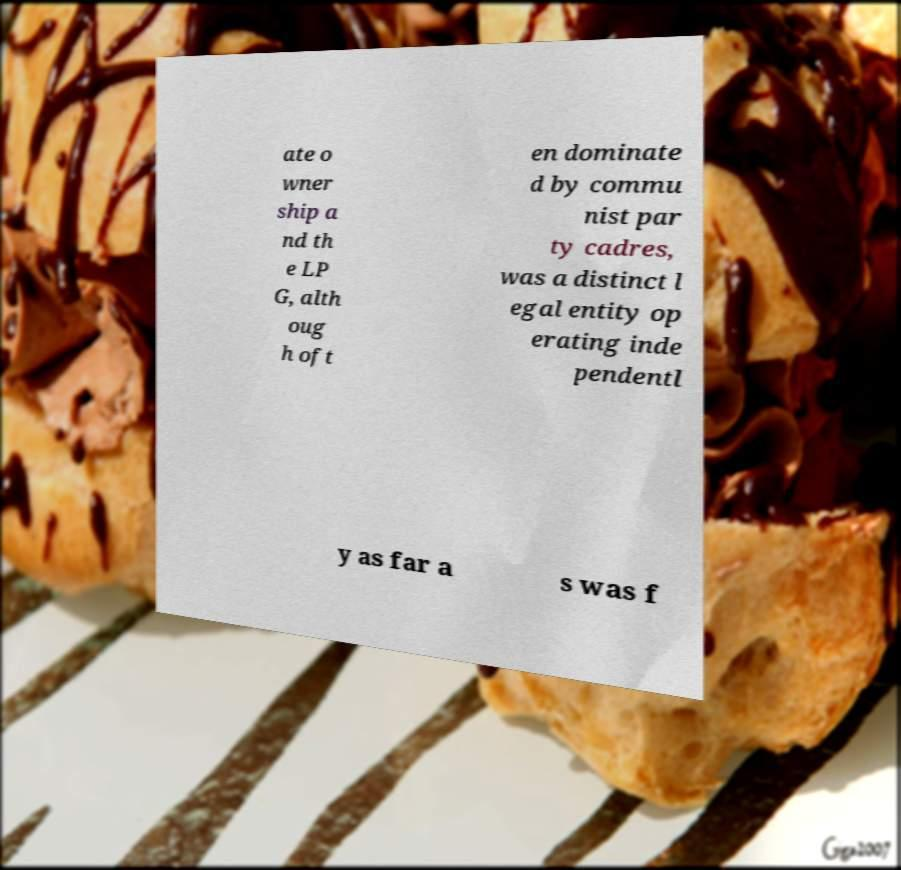There's text embedded in this image that I need extracted. Can you transcribe it verbatim? ate o wner ship a nd th e LP G, alth oug h oft en dominate d by commu nist par ty cadres, was a distinct l egal entity op erating inde pendentl y as far a s was f 